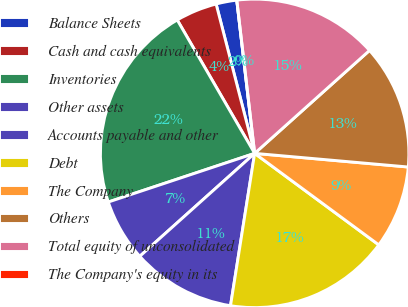Convert chart to OTSL. <chart><loc_0><loc_0><loc_500><loc_500><pie_chart><fcel>Balance Sheets<fcel>Cash and cash equivalents<fcel>Inventories<fcel>Other assets<fcel>Accounts payable and other<fcel>Debt<fcel>The Company<fcel>Others<fcel>Total equity of unconsolidated<fcel>The Company's equity in its<nl><fcel>2.17%<fcel>4.35%<fcel>21.74%<fcel>6.52%<fcel>10.87%<fcel>17.39%<fcel>8.7%<fcel>13.04%<fcel>15.22%<fcel>0.0%<nl></chart> 